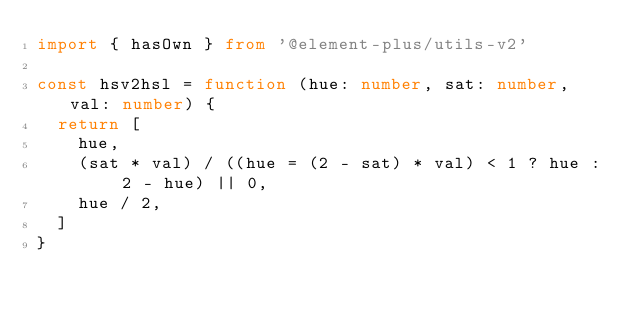<code> <loc_0><loc_0><loc_500><loc_500><_TypeScript_>import { hasOwn } from '@element-plus/utils-v2'

const hsv2hsl = function (hue: number, sat: number, val: number) {
  return [
    hue,
    (sat * val) / ((hue = (2 - sat) * val) < 1 ? hue : 2 - hue) || 0,
    hue / 2,
  ]
}
</code> 